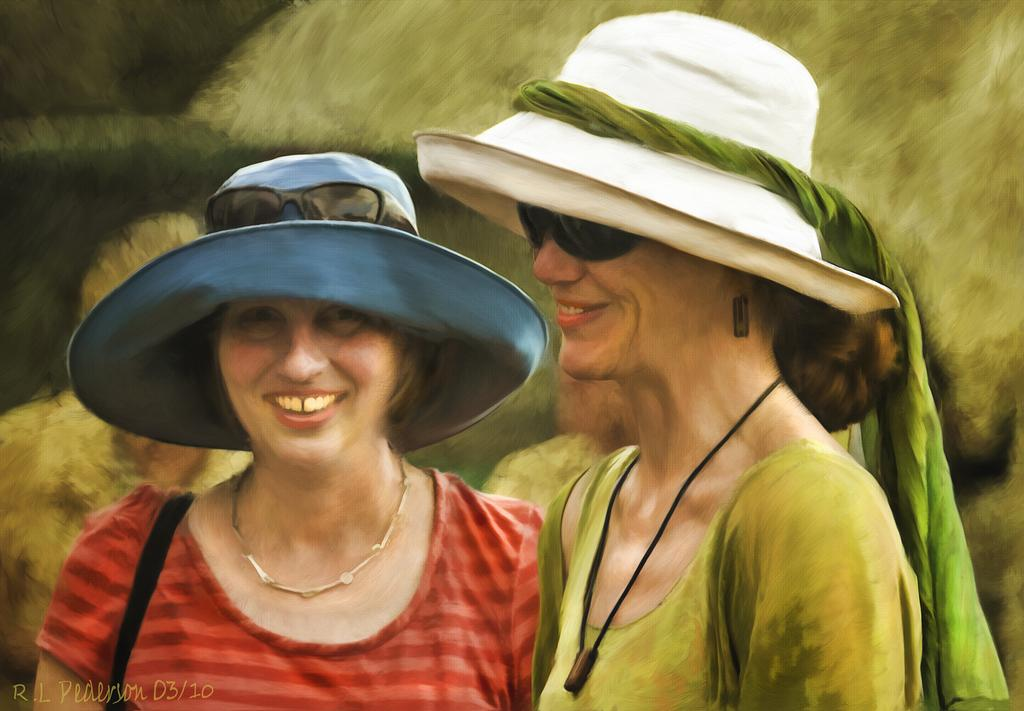How many women are present in the image? There are two women in the image. What are the women wearing on their heads? The women are wearing caps. What type of circle can be seen in the image? There is no circle present in the image. What type of meat is being prepared by the women in the image? There is no meat or any indication of food preparation in the image. 